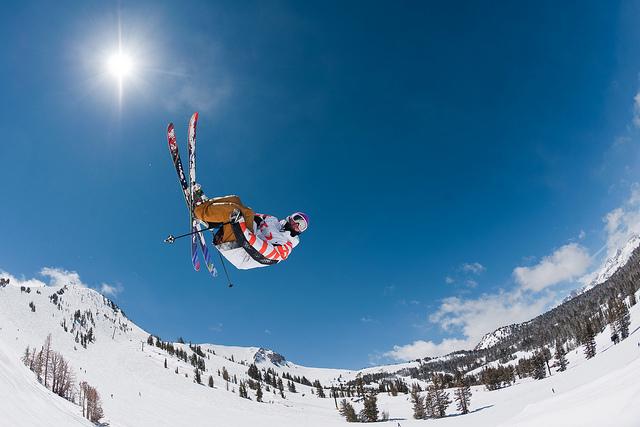What sport is shown?
Write a very short answer. Skiing. What sport is this?
Short answer required. Skiing. What is in the sky?
Keep it brief. Sun. Was this picture taken in a city?
Answer briefly. No. What is in the background?
Short answer required. Snow. Is he surfing?
Short answer required. No. Is there a crowd watching?
Short answer required. No. 